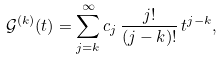Convert formula to latex. <formula><loc_0><loc_0><loc_500><loc_500>\mathcal { G } ^ { ( k ) } ( t ) = \sum _ { j = k } ^ { \infty } c _ { j } \, \frac { j ! } { ( j - k ) ! } \, t ^ { j - k } ,</formula> 